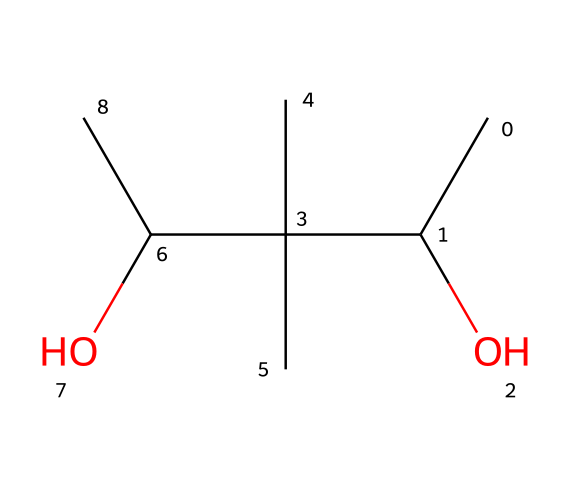What is the molecular formula of the chemical represented by the SMILES? To determine the molecular formula, we need to count the number of carbon (C), hydrogen (H), and oxygen (O) atoms in the structure from the SMILES. There are 6 carbons, 12 hydrogens, and 2 oxygens, leading to the formula C6H12O2.
Answer: C6H12O2 How many hydroxyl (–OH) groups are present in this molecule? By analyzing the structure indicated by the SMILES, we can see there are two –OH groups present: one at either of the two carbon atoms that are connected to oxygen atoms.
Answer: 2 What type of polymer is polyvinyl alcohol classified as? Polyvinyl alcohol is a water-soluble synthetic polymer, primarily consisting of repeated vinyl alcohol units. It is typically used in the formation of films and hydrogels.
Answer: synthetic polymer Can this chemical create a non-Newtonian fluid? Yes, when polyvinyl alcohol is dissolved in water, it can exhibit non-Newtonian behavior, specifically shear-thinning viscosity under stress, which is a characteristic of many polymers.
Answer: Yes How does the molecular structure contribute to its non-Newtonian properties? The molecular structure, featuring long chains and hydroxyl groups, allows the polymer chains to interact and entangle, producing a thickening effect under shear stress. This prevents easy flow, characteristic of non-Newtonian fluids.
Answer: entanglement What is the major application of polyvinyl alcohol in music performances? In music performances, polyvinyl alcohol is primarily used to create non-toxic stage blood due to its ability to mimic the appearance and viscosity of real blood without the health risks.
Answer: stage blood 